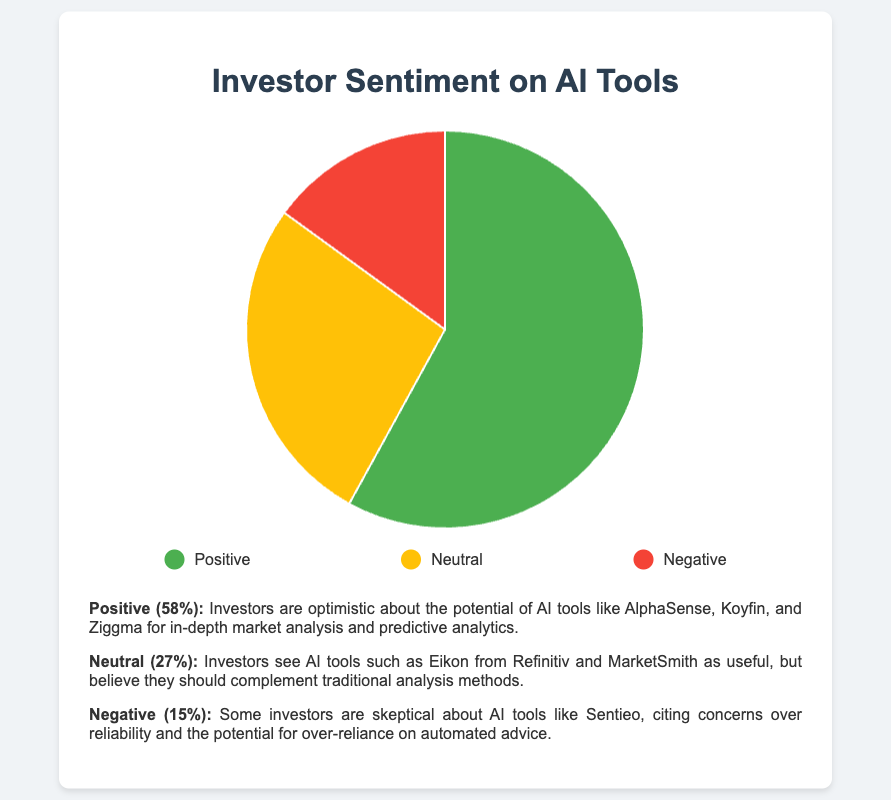What's the category with the highest investor sentiment percentage? The pie chart shows the distribution of investor sentiment percentages among three categories. The category 'Positive' has the largest portion of the pie.
Answer: Positive What percentage of investors have a neutral sentiment about AI tools? By looking at the pie chart, the segment labeled 'Neutral' represents 27% of the total sentiment distribution.
Answer: 27% How much more positive sentiment is there compared to negative sentiment? The 'Positive' segment shows 58% and the 'Negative' segment shows 15%. Subtract the negative sentiment from the positive sentiment: 58% - 15% = 43%.
Answer: 43% What is the combined percentage of neutral and negative sentiments? The 'Neutral' segment is 27% and the 'Negative' segment is 15%. Adding these two gives: 27% + 15% = 42%.
Answer: 42% Which category has the smallest proportion of investor sentiment? The smallest segment of the pie chart is labeled 'Negative', representing 15% of the sentiment distribution.
Answer: Negative What is the ratio of positive to neutral sentiment percentages? The 'Positive' segment is 58% and the 'Neutral' segment is 27%. The ratio is calculated by dividing the positive percentage by the neutral percentage: 58 / 27 ≈ 2.15.
Answer: 2.15 By how many percentage points does the positive sentiment exceed the combined neutral and negative sentiments? The combined 'Neutral' and 'Negative' sentiments are 42% (27% + 15%). The 'Positive' sentiment is 58%. Subtract the combined percentage from the positive percentage: 58% - 42% = 16%.
Answer: 16% What color represents the neutral sentiment in the pie chart? The legend indicates that the 'Neutral' sentiment is represented by the color yellow in the pie chart.
Answer: Yellow 